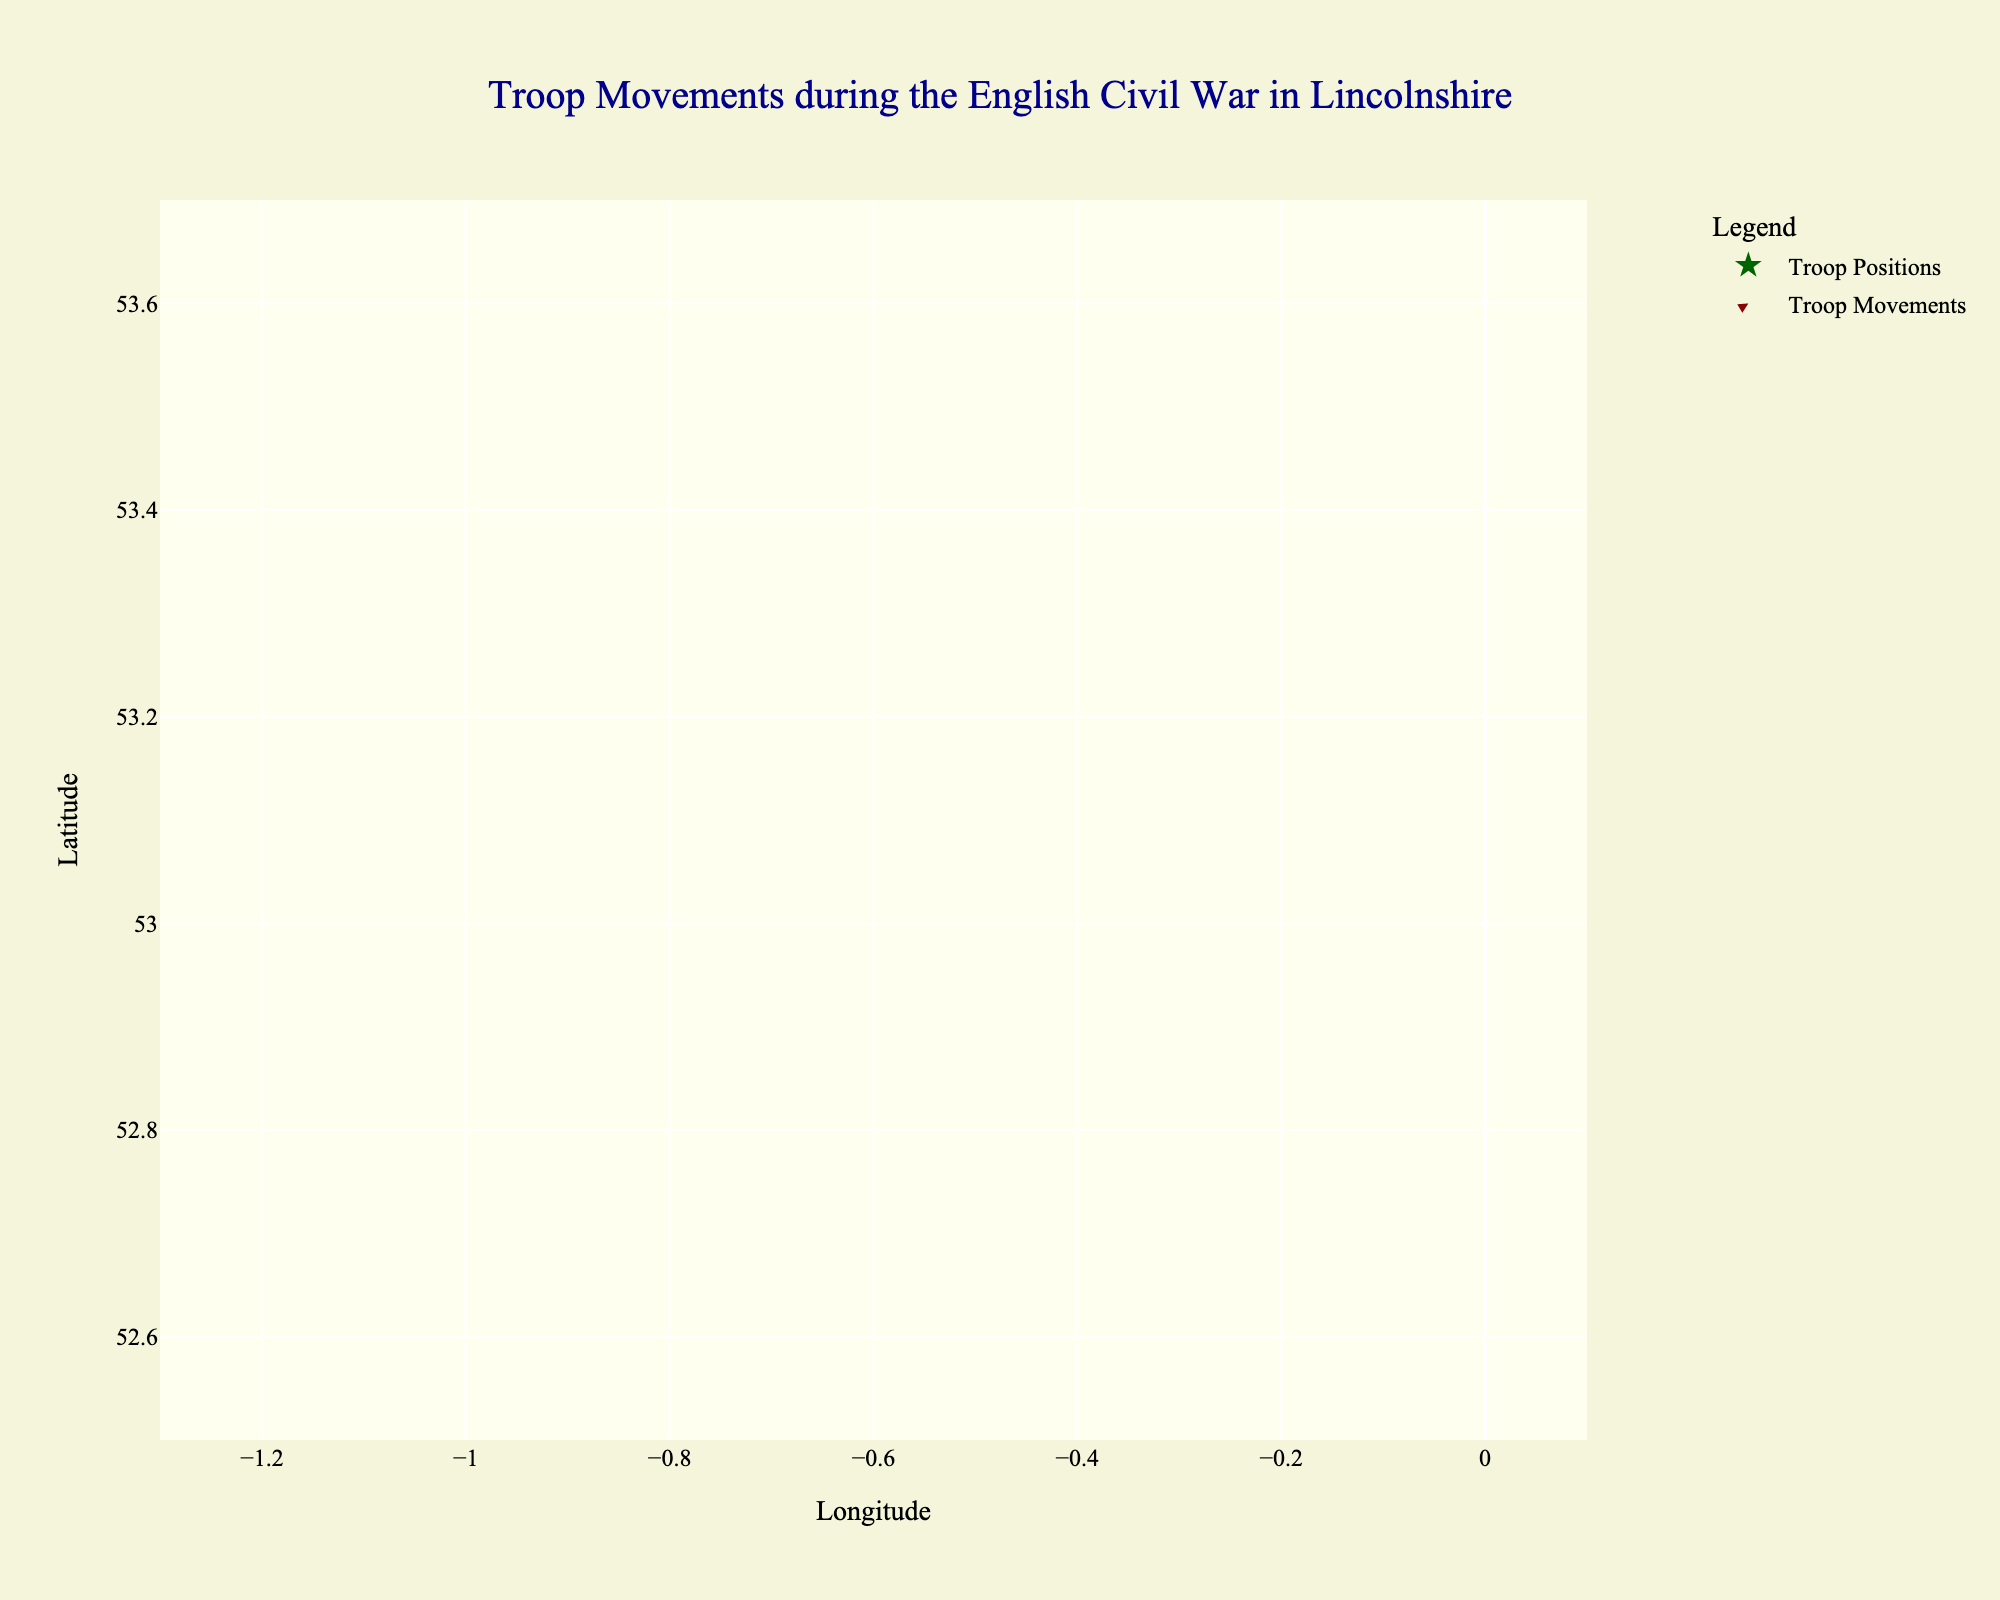What is the title of the plot? The title can be found at the top of the plot. It reads "Troop Movements during the English Civil War in Lincolnshire".
Answer: Troop Movements during the English Civil War in Lincolnshire How many troop movements are represented in the plot? Each troop movement is represented by an arrow marker pointing in the direction of the movement. By counting the arrows, we can determine the number.
Answer: 10 Which troop movement originates from Lincoln? Look for the entry with the label "Royalist forces from Lincoln" and trace its corresponding arrow marker.
Answer: Royalist forces What is the direction of Cromwell's cavalry from Gainsborough? The arrow originating at the position labeled "Cromwell's cavalry from Gainsborough" points towards the top-right (up and to the right). This direction is represented by the vectors u=0.2 and v=0.6.
Answer: Towards the northeast How many troop movements are directed towards Chesterfield? Chesterfield is located roughly towards the west/northwest. By labeling and observing the relevant directions, we'll count the arrows pointing in that direction, particularly the "Royalist retreat towards Chesterfield" entry.
Answer: One Which forces are showing the largest magnitude of movement? To identify the largest movement, calculate the magnitudes of each vector; movement magnitude can be calculated using √(u² + v²).
Answer: Parliamentary militia from Boston Between Royalist forces from Lincoln and Parliamentary troops from Newark, which travelled farther and in what direction did they move? Calculate the magnitudes of the corresponding vectors (-0.5, 0.3) for Lincoln and (0.3, -0.4) for Newark. The magnitude of vectors can be calculated using √(u² + v²). Compare the results to verify which is farther.
Answer: Parliamentary troops from Newark, southeast What is the average latitude position of all the forces? Sum all the y values and divide by the number of data points: \(\frac{53.2307 + 52.9548 + 53.5741 + 52.7730 + 53.0765 + 53.2327 + 52.6369 + 53.4084 + 52.8384 + 53.3472}{10}\). Calculate to find the average.
Answer: Approx. 53.0075 Which troops are moving directly southward? Troops moving directly south would have a negative v component and near-zero u component. The "Royalist supply line from Scunthorpe" has (u = -0.2, v = -0.5).
Answer: Royalist supply line from Scunthorpe What is the combined movement vector of all Royalist forces? Sum the vectors of all Royalist forces: (-0.5, 0.3) + (-0.4, -0.2) + (-0.3, 0.5) + (-0.2, -0.5) + (-0.3, -0.3). Sum u components and v components separately: \(-1.7, -0.2\).
Answer: (-1.7, -0.2) 